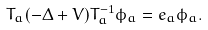Convert formula to latex. <formula><loc_0><loc_0><loc_500><loc_500>T _ { a } ( - \Delta + V ) T _ { a } ^ { - 1 } \phi _ { a } = e _ { a } \phi _ { a } .</formula> 